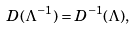<formula> <loc_0><loc_0><loc_500><loc_500>D ( \Lambda ^ { - 1 } ) = D ^ { - 1 } ( \Lambda ) ,</formula> 